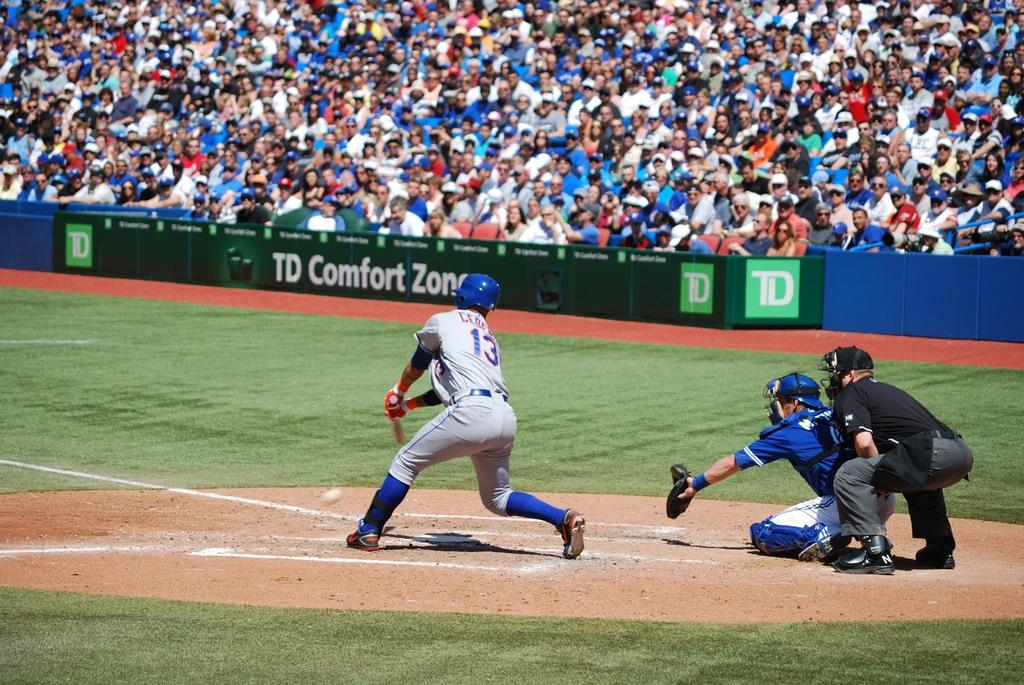<image>
Present a compact description of the photo's key features. A baseball game is underway and the stadium is full and says TD Comfort Zone. 